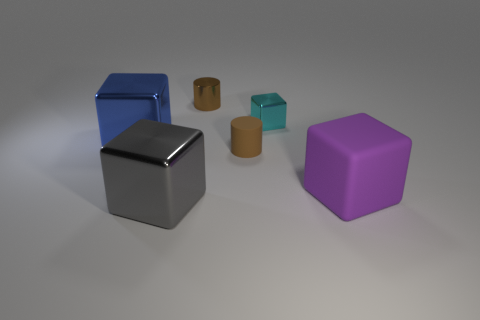What's the texture of the objects like, based on their appearance? The objects in the image have a smooth and polished texture, indicating that they might have a metallic or plastic finish. This gives the objects a reflective surface that interacts with the light source in the scene. 